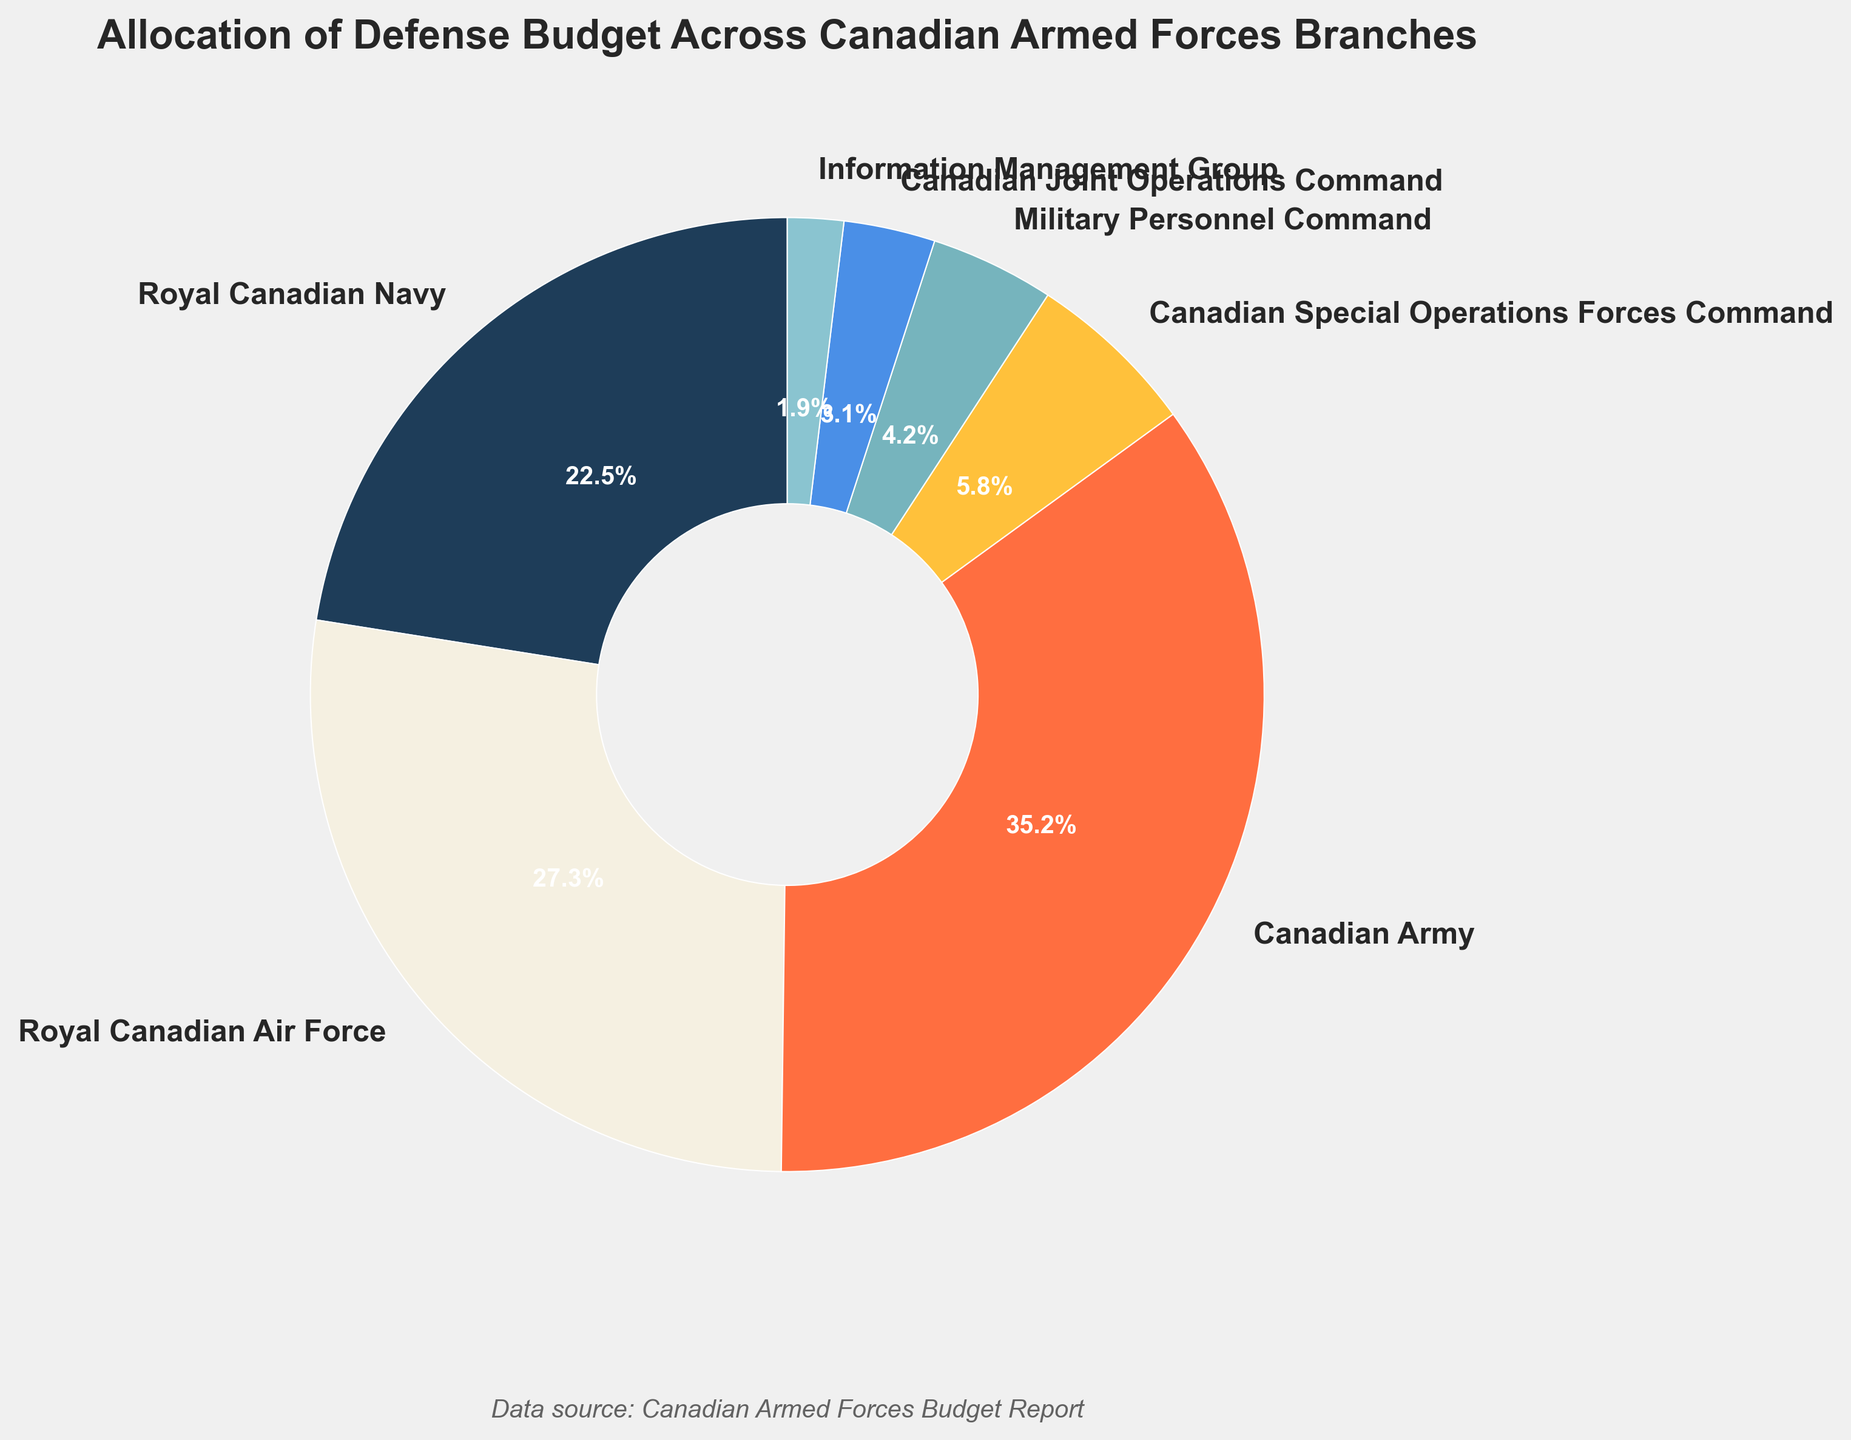What is the largest budget allocation percentage and which branch does it represent? The largest slice in the pie chart corresponds to the branch with the highest budget allocation. From the chart, the Canadian Army holds the largest percentage.
Answer: 35.2%, Canadian Army Which branch has the smallest budget allocation? The smallest slice in the pie chart represents the branch with the lowest budget allocation. Observing the chart, it is the Information Management Group.
Answer: 1.9%, Information Management Group What is the total budget allocation percentage for the Royal Canadian Navy and the Royal Canadian Air Force combined? To find the combined budget allocation for the Royal Canadian Navy and the Royal Canadian Air Force, add their individual percentages: 22.5% + 27.3% = 49.8%.
Answer: 49.8% How much greater is the budget allocation for the Canadian Army compared to the Canadian Special Operations Forces Command? Subtract the budget allocation of the Canadian Special Operations Forces Command from that of the Canadian Army: 35.2% - 5.8% = 29.4%.
Answer: 29.4% Which branches have a budget allocation percentage greater than 10%? The branches with wedges representing more than 10% in the pie chart are the ones with visible larger slices than others. These are the Royal Canadian Navy, Royal Canadian Air Force, and Canadian Army.
Answer: Royal Canadian Navy, Royal Canadian Air Force, Canadian Army What is the combined budget allocation percentage for the branches under 5%? Sum the percentages of branches with less than 5% allocation: Canadian Special Operations Forces Command (5.8% is over 5%), Military Personnel Command (4.2%), Canadian Joint Operations Command (3.1%), and Information Management Group (1.9%). Total = 4.2% + 3.1% + 1.9% = 9.2%.
Answer: 9.2% Compare the budget allocations of Military Personnel Command and Canadian Joint Operations Command. Which one has a greater allocation and by how much? The difference in their budget allocations is found by subtracting the smaller value from the larger one: 4.2% (Military Personnel Command) - 3.1% (Canadian Joint Operations Command) = 1.1%.
Answer: Military Personnel Command, 1.1% What is the average budget allocation percentage for all branches? Add up all percentages and divide by the number of branches: (22.5% + 27.3% + 35.2% + 5.8% + 4.2% + 3.1% + 1.9%) / 7 ≈ 14.29%.
Answer: 14.29% Identify the branch represented by a blue color and its budget allocation. In the chart, the branch represented by a blue-colored slice has a specific budget allocation. Based on typical pie chart color-coding, it’s the Royal Canadian Navy.
Answer: Royal Canadian Navy, 22.5% 